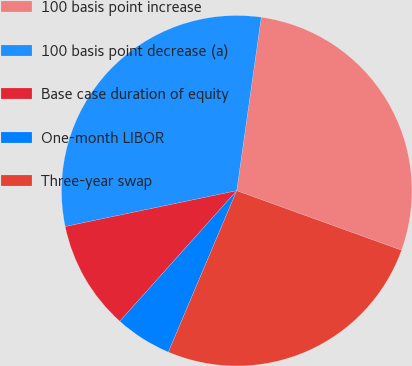Convert chart to OTSL. <chart><loc_0><loc_0><loc_500><loc_500><pie_chart><fcel>100 basis point increase<fcel>100 basis point decrease (a)<fcel>Base case duration of equity<fcel>One-month LIBOR<fcel>Three-year swap<nl><fcel>28.28%<fcel>30.51%<fcel>10.1%<fcel>5.25%<fcel>25.86%<nl></chart> 